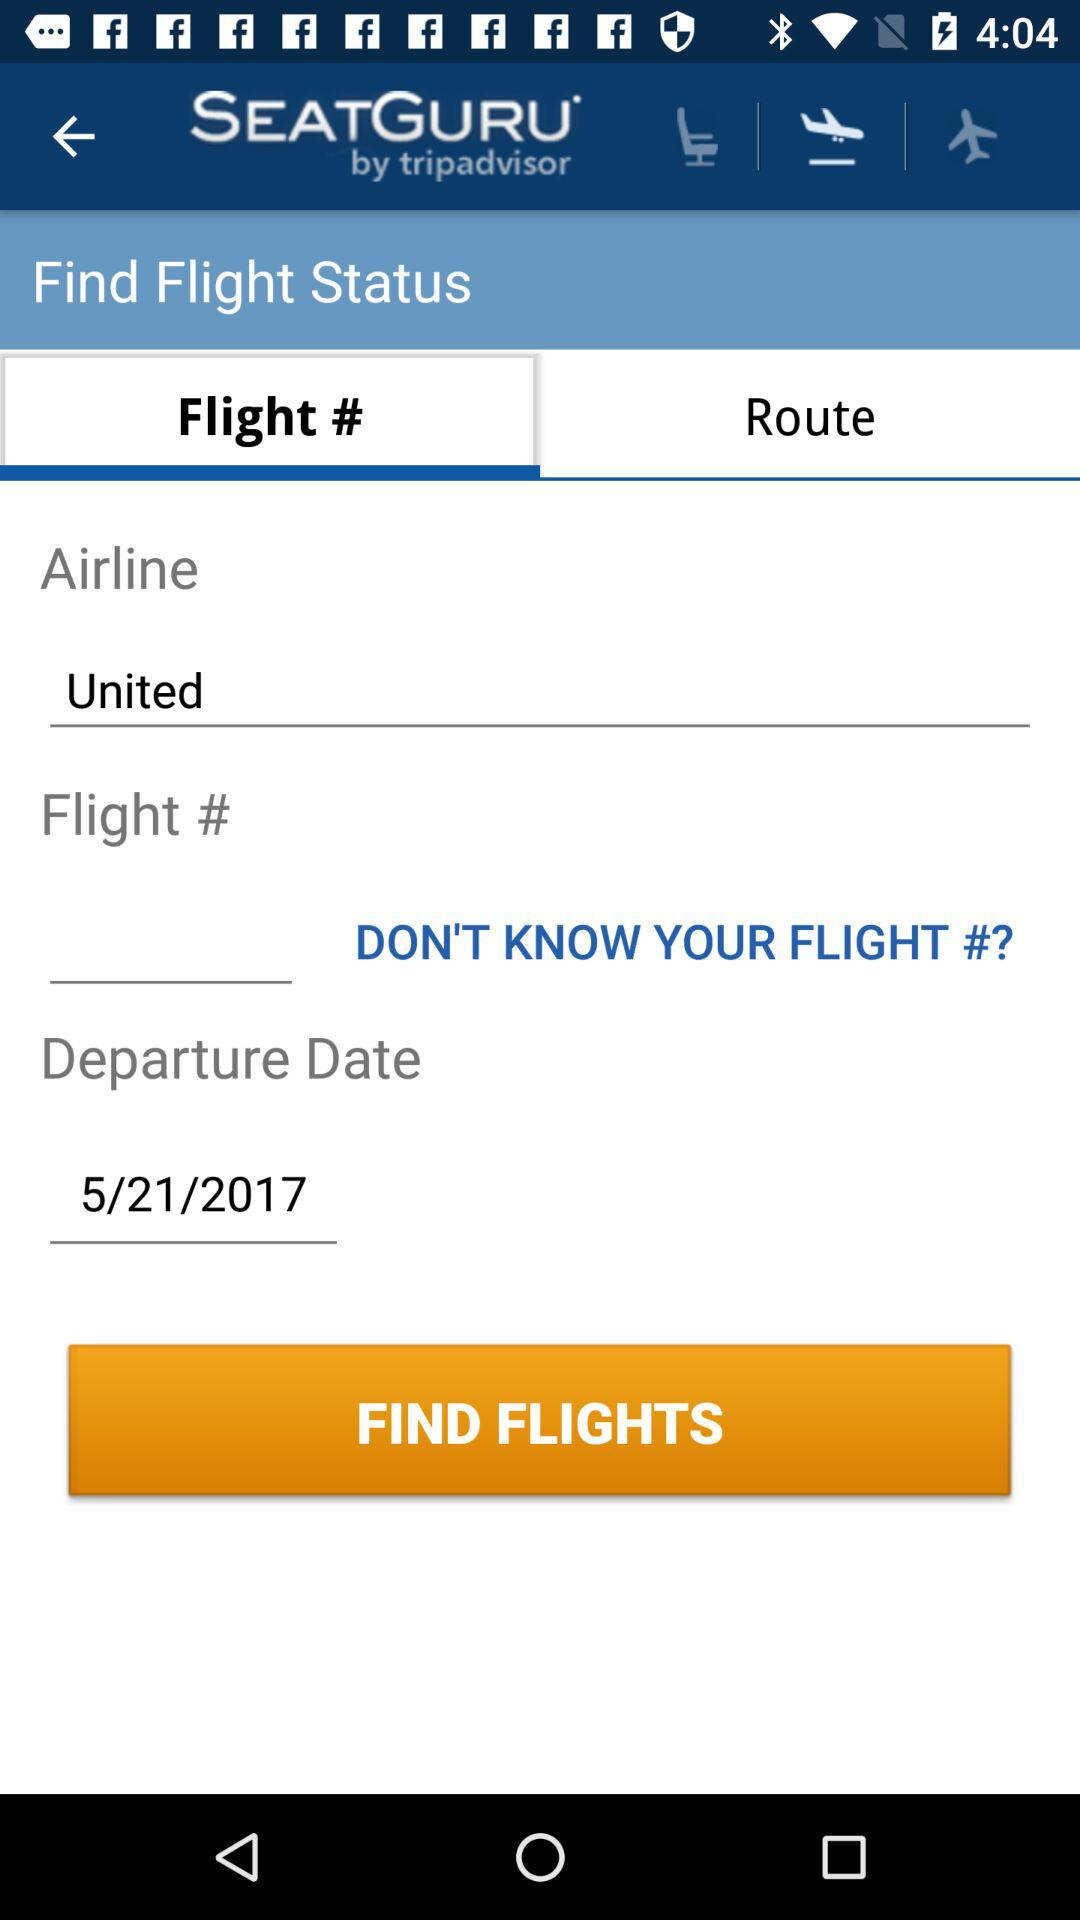What's the airline name? The airline name is "United". 